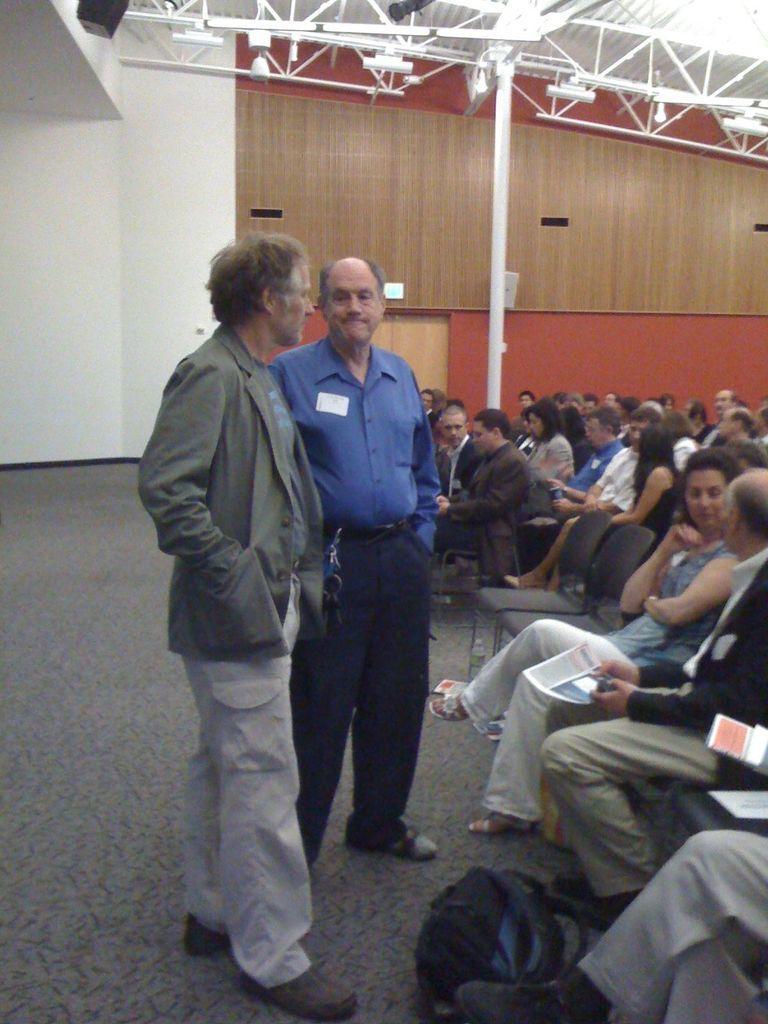Please provide a concise description of this image. This picture is taken inside the room. In this image, on the right side, we can see a man sitting on the chair, on the right side, we can see a bag. In the middle of the image, we can see two men are standing on the floor. In the background, we can see a door which is closed. At the top, we can see a metal instrument and a pole. 